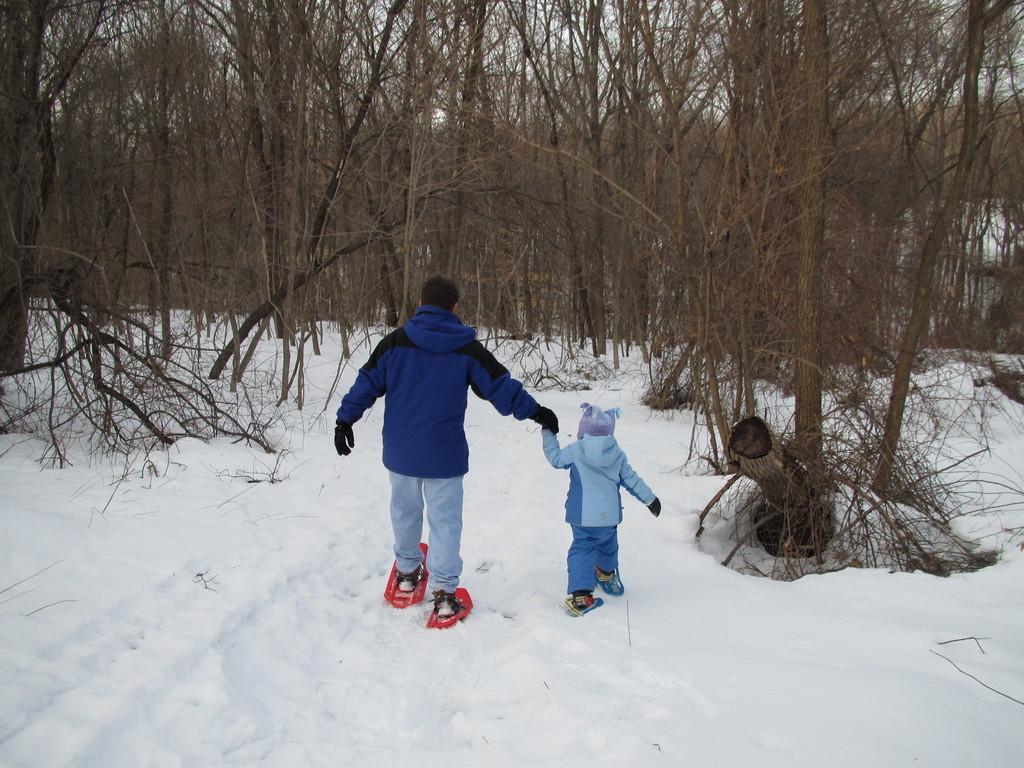Please provide a concise description of this image. In this image we can see two persons standing on the skiboards, there are some trees and the snow, in the background we can see the sky. 